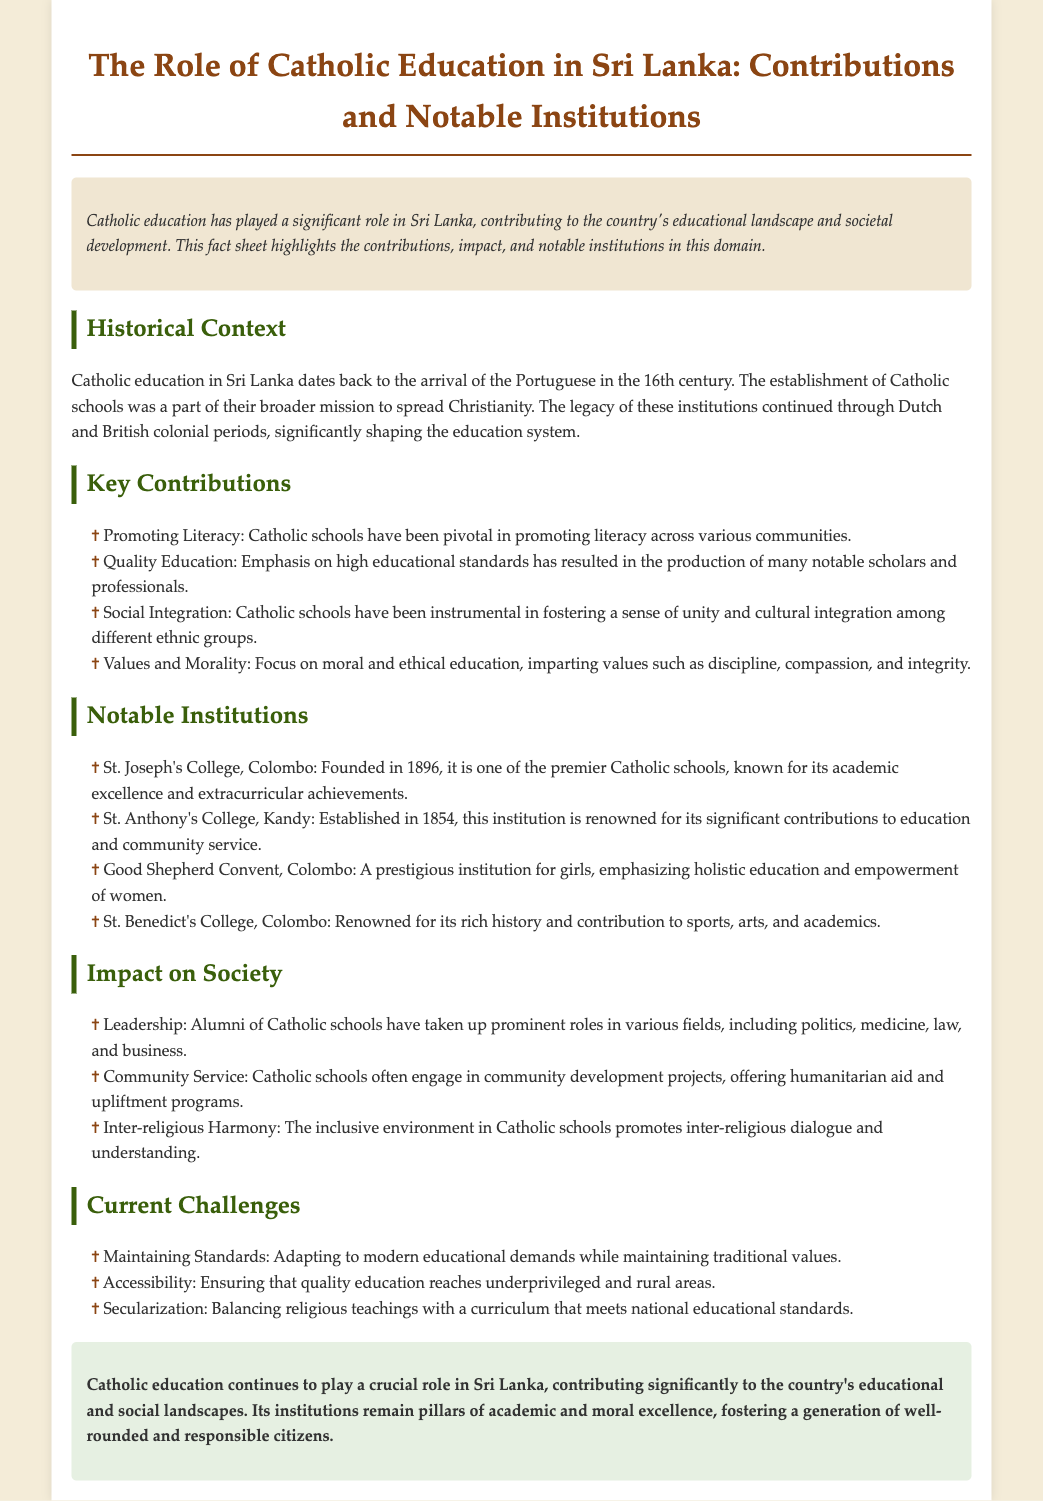What year was St. Joseph's College, Colombo founded? The founding year of St. Joseph's College is mentioned in the notable institutions section, which states it was founded in 1896.
Answer: 1896 What is a key contribution of Catholic education in Sri Lanka? This information can be found in the key contributions section, detailing various roles Catholic education has played, such as promoting literacy.
Answer: Promoting Literacy Which institution is noted for emphasizing the empowerment of women? The notable institutions section highlights the Good Shepherd Convent for its focus on women's education and empowerment.
Answer: Good Shepherd Convent What is one current challenge faced by Catholic education? The current challenges section lists various issues, and maintaining standards is one of them.
Answer: Maintaining Standards In what year was St. Anthony's College, Kandy established? The establishment year of St. Anthony's College is provided in the notable institutions section, which states it was established in 1854.
Answer: 1854 How has Catholic education contributed to inter-religious dialogue? The impact section mentions that Catholic schools promote an inclusive environment, which fosters inter-religious dialogue.
Answer: Inter-religious Harmony What are the main periods of Catholic education history in Sri Lanka? The historical context describes the significant periods including the Portuguese, Dutch, and British colonial eras.
Answer: Portuguese, Dutch, British Which famous college is associated with sports, arts, and academics? The document mentions St. Benedict's College in the notable institutions section as renowned for these areas.
Answer: St. Benedict's College 